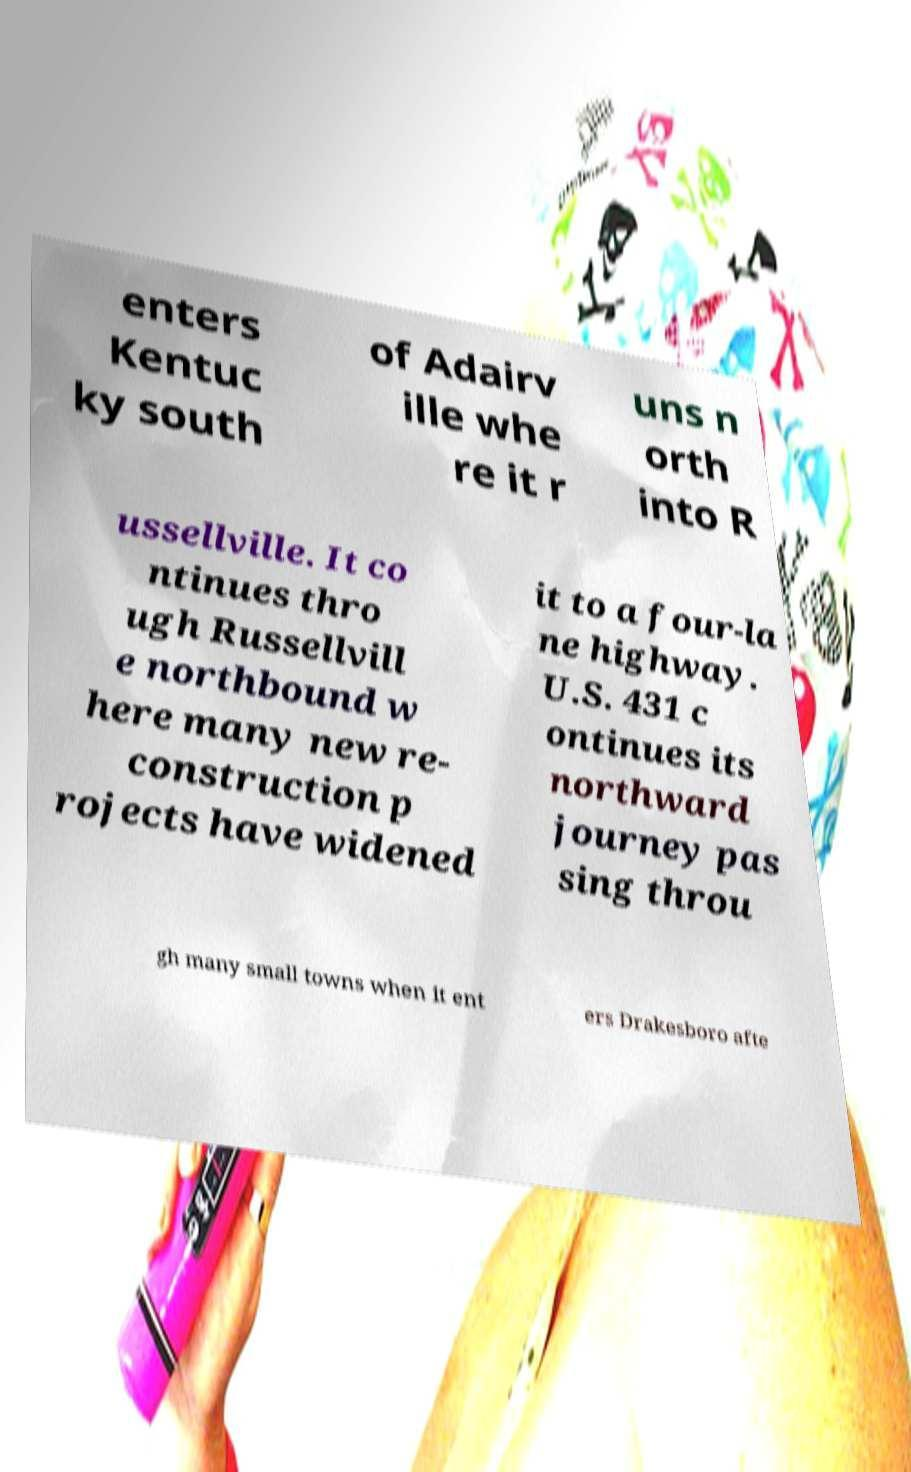Could you assist in decoding the text presented in this image and type it out clearly? enters Kentuc ky south of Adairv ille whe re it r uns n orth into R ussellville. It co ntinues thro ugh Russellvill e northbound w here many new re- construction p rojects have widened it to a four-la ne highway. U.S. 431 c ontinues its northward journey pas sing throu gh many small towns when it ent ers Drakesboro afte 